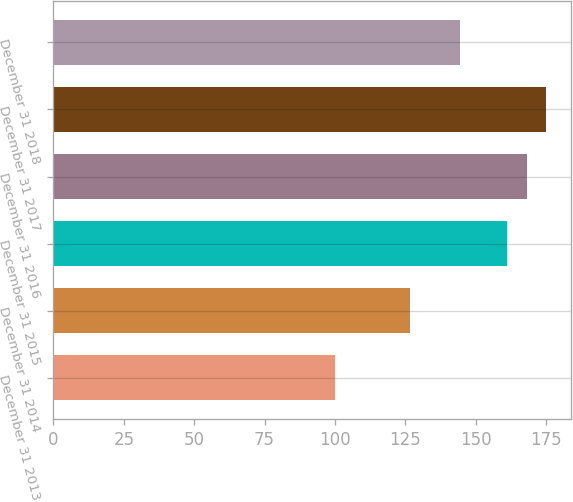Convert chart. <chart><loc_0><loc_0><loc_500><loc_500><bar_chart><fcel>December 31 2013<fcel>December 31 2014<fcel>December 31 2015<fcel>December 31 2016<fcel>December 31 2017<fcel>December 31 2018<nl><fcel>100<fcel>126.77<fcel>161.15<fcel>168.11<fcel>175.07<fcel>144.41<nl></chart> 